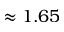<formula> <loc_0><loc_0><loc_500><loc_500>\approx 1 . 6 5</formula> 